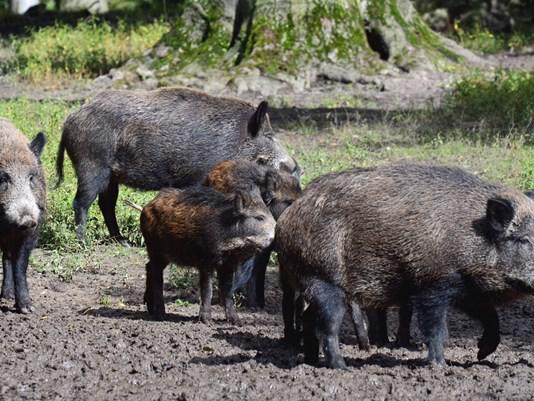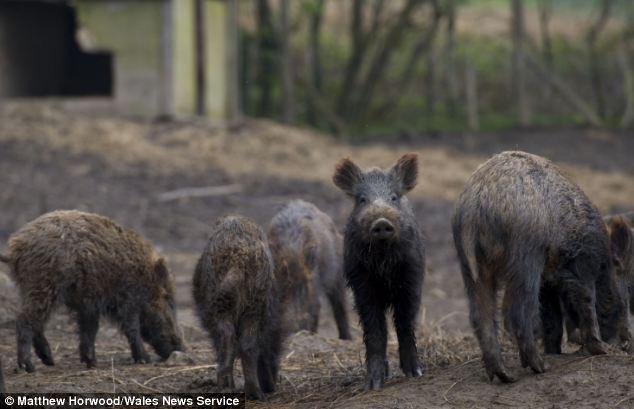The first image is the image on the left, the second image is the image on the right. Evaluate the accuracy of this statement regarding the images: "The left photo contains two or fewer boars.". Is it true? Answer yes or no. No. The first image is the image on the left, the second image is the image on the right. Evaluate the accuracy of this statement regarding the images: "The left image contains no more than two wild boars.". Is it true? Answer yes or no. No. 